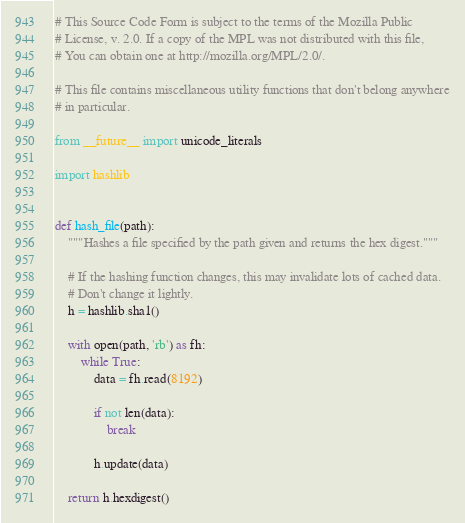<code> <loc_0><loc_0><loc_500><loc_500><_Python_># This Source Code Form is subject to the terms of the Mozilla Public
# License, v. 2.0. If a copy of the MPL was not distributed with this file,
# You can obtain one at http://mozilla.org/MPL/2.0/.

# This file contains miscellaneous utility functions that don't belong anywhere
# in particular.

from __future__ import unicode_literals

import hashlib


def hash_file(path):
    """Hashes a file specified by the path given and returns the hex digest."""

    # If the hashing function changes, this may invalidate lots of cached data.
    # Don't change it lightly.
    h = hashlib.sha1()

    with open(path, 'rb') as fh:
        while True:
            data = fh.read(8192)

            if not len(data):
                break

            h.update(data)

    return h.hexdigest()
</code> 